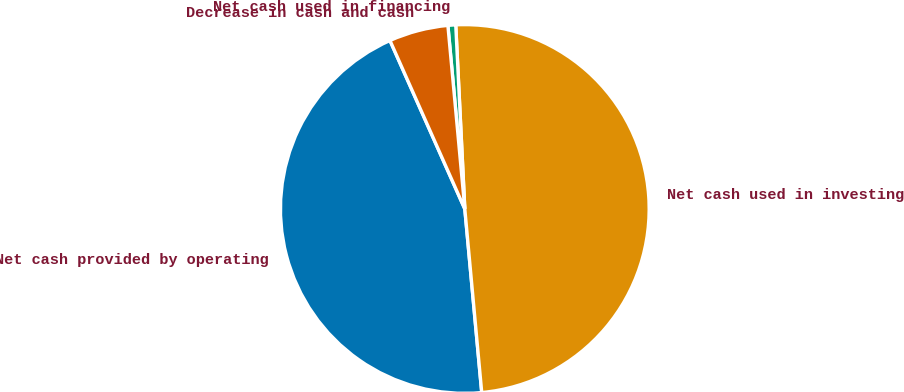<chart> <loc_0><loc_0><loc_500><loc_500><pie_chart><fcel>Net cash provided by operating<fcel>Net cash used in investing<fcel>Net cash used in financing<fcel>Decrease in cash and cash<nl><fcel>44.81%<fcel>49.32%<fcel>0.68%<fcel>5.19%<nl></chart> 